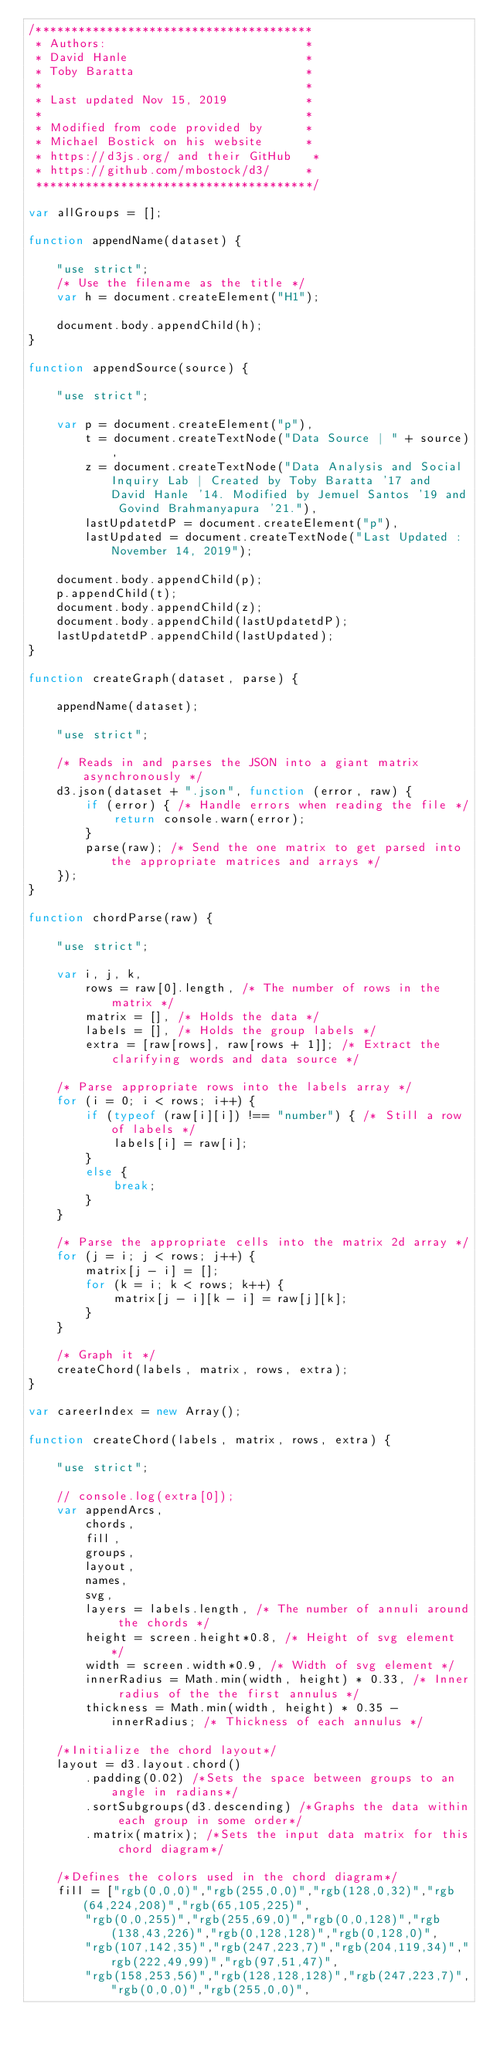Convert code to text. <code><loc_0><loc_0><loc_500><loc_500><_JavaScript_>/***************************************
 * Authors:                            *
 * David Hanle                         *
 * Toby Baratta                        *
 *                                     *
 * Last updated Nov 15, 2019           *
 *                                     *
 * Modified from code provided by      *
 * Michael Bostick on his website      *
 * https://d3js.org/ and their GitHub   *
 * https://github.com/mbostock/d3/     *
 ***************************************/

var allGroups = [];

function appendName(dataset) {

    "use strict";
    /* Use the filename as the title */
    var h = document.createElement("H1");

    document.body.appendChild(h);
}

function appendSource(source) {

    "use strict";

    var p = document.createElement("p"),
        t = document.createTextNode("Data Source | " + source),
        z = document.createTextNode("Data Analysis and Social Inquiry Lab | Created by Toby Baratta '17 and David Hanle '14. Modified by Jemuel Santos '19 and Govind Brahmanyapura '21."),
        lastUpdatetdP = document.createElement("p"),
        lastUpdated = document.createTextNode("Last Updated : November 14, 2019");

    document.body.appendChild(p);
    p.appendChild(t);
    document.body.appendChild(z);
    document.body.appendChild(lastUpdatetdP);
    lastUpdatetdP.appendChild(lastUpdated);
}

function createGraph(dataset, parse) {

    appendName(dataset);

    "use strict";

    /* Reads in and parses the JSON into a giant matrix asynchronously */
    d3.json(dataset + ".json", function (error, raw) {
        if (error) { /* Handle errors when reading the file */
            return console.warn(error);
        }
        parse(raw); /* Send the one matrix to get parsed into the appropriate matrices and arrays */
    });
}

function chordParse(raw) {

    "use strict";

    var i, j, k,
        rows = raw[0].length, /* The number of rows in the matrix */
        matrix = [], /* Holds the data */
        labels = [], /* Holds the group labels */
        extra = [raw[rows], raw[rows + 1]]; /* Extract the clarifying words and data source */

    /* Parse appropriate rows into the labels array */
    for (i = 0; i < rows; i++) {
        if (typeof (raw[i][i]) !== "number") { /* Still a row of labels */
            labels[i] = raw[i];
        }
        else {
            break;
        }
    }

    /* Parse the appropriate cells into the matrix 2d array */
    for (j = i; j < rows; j++) {
        matrix[j - i] = [];
        for (k = i; k < rows; k++) {
            matrix[j - i][k - i] = raw[j][k];
        }
    }

    /* Graph it */
    createChord(labels, matrix, rows, extra);
}

var careerIndex = new Array();

function createChord(labels, matrix, rows, extra) {

    "use strict";

    // console.log(extra[0]);
    var appendArcs,
        chords,
        fill,
        groups,
        layout,
        names,
        svg,
        layers = labels.length, /* The number of annuli around the chords */
        height = screen.height*0.8, /* Height of svg element */
        width = screen.width*0.9, /* Width of svg element */
        innerRadius = Math.min(width, height) * 0.33, /* Inner radius of the the first annulus */
        thickness = Math.min(width, height) * 0.35 - innerRadius; /* Thickness of each annulus */

    /*Initialize the chord layout*/
    layout = d3.layout.chord()
        .padding(0.02) /*Sets the space between groups to an angle in radians*/
        .sortSubgroups(d3.descending) /*Graphs the data within each group in some order*/
        .matrix(matrix); /*Sets the input data matrix for this chord diagram*/

    /*Defines the colors used in the chord diagram*/
    fill = ["rgb(0,0,0)","rgb(255,0,0)","rgb(128,0,32)","rgb(64,224,208)","rgb(65,105,225)",
        "rgb(0,0,255)","rgb(255,69,0)","rgb(0,0,128)","rgb(138,43,226)","rgb(0,128,128)","rgb(0,128,0)",
        "rgb(107,142,35)","rgb(247,223,7)","rgb(204,119,34)","rgb(222,49,99)","rgb(97,51,47)",
        "rgb(158,253,56)","rgb(128,128,128)","rgb(247,223,7)","rgb(0,0,0)","rgb(255,0,0)",</code> 